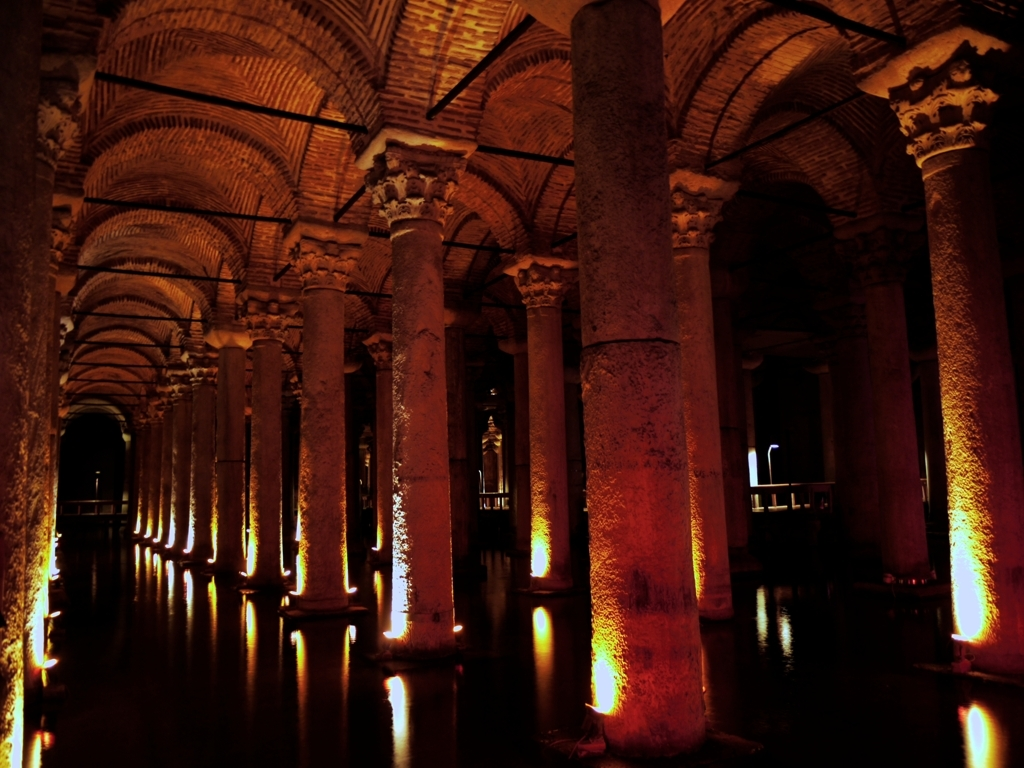How does the lighting affect the atmosphere of the place? The lighting in this image creates a warm and dramatic ambiance. The way the light casts soft glows on the pillars and reflects on the water surface adds an element of serenity and mystery, enhancing the viewer's emotional response to the space. 